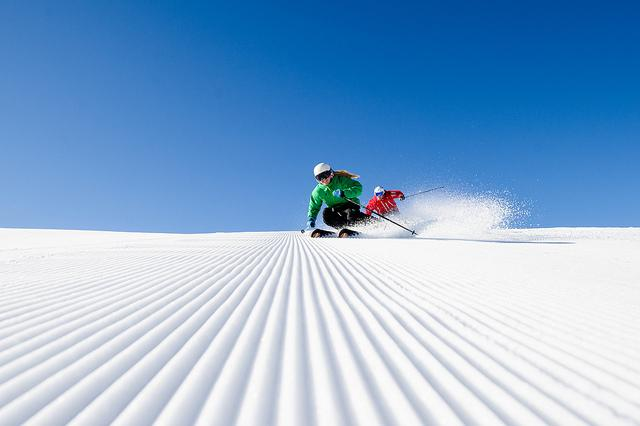The person in the lead is wearing what color jacket? Please explain your reasoning. green. The people are clearly visible and the person closer to the bottom and thus in the lead is wearing a green jacket. 